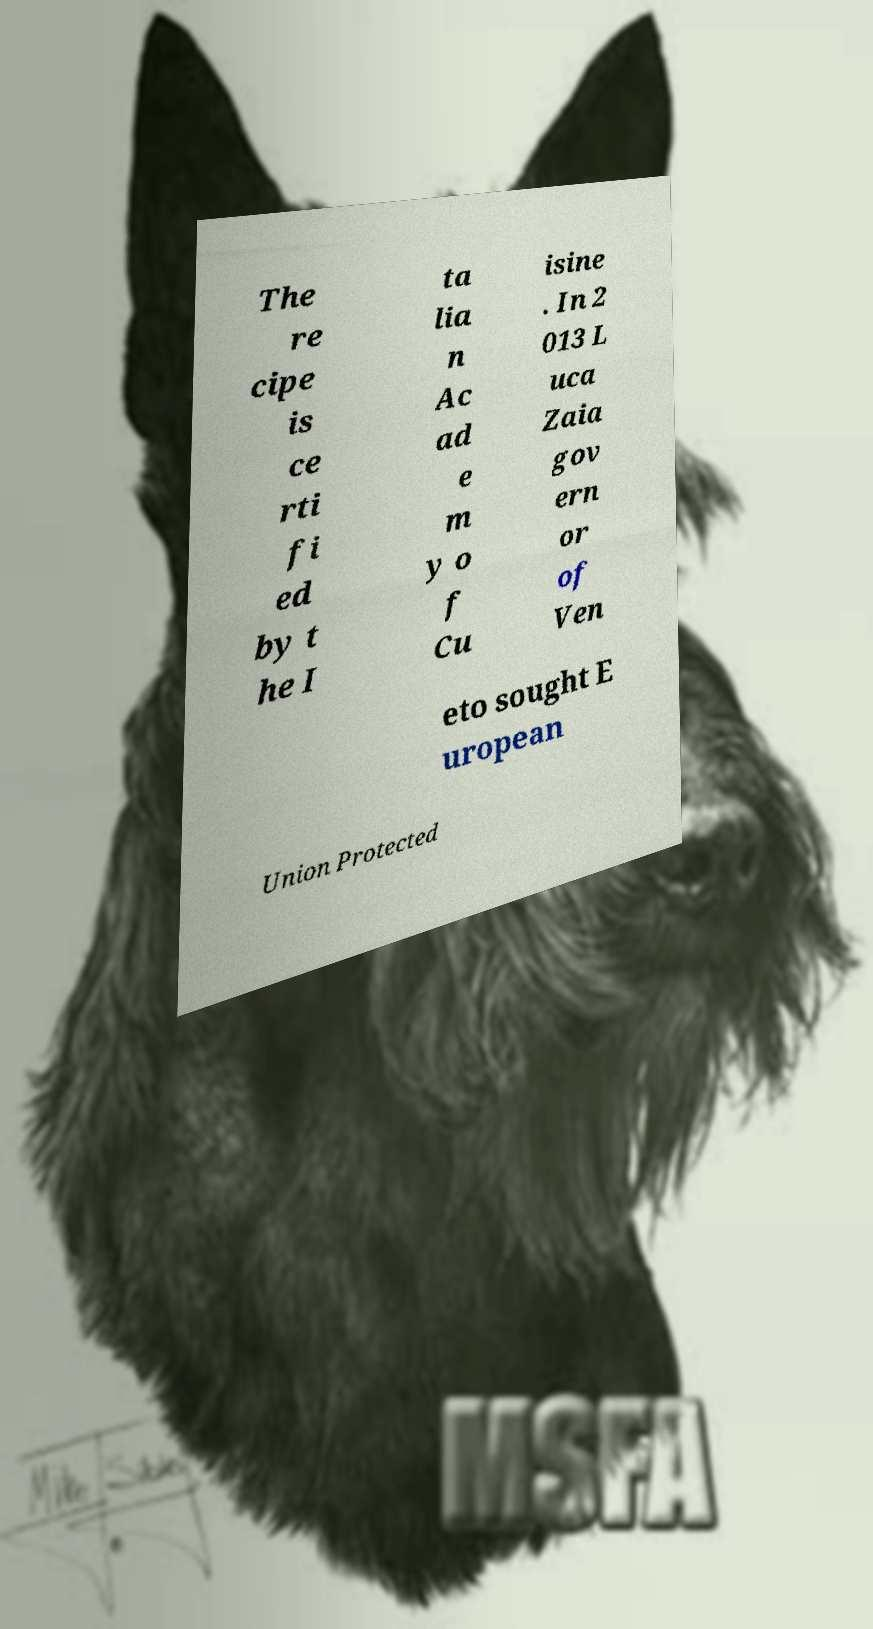There's text embedded in this image that I need extracted. Can you transcribe it verbatim? The re cipe is ce rti fi ed by t he I ta lia n Ac ad e m y o f Cu isine . In 2 013 L uca Zaia gov ern or of Ven eto sought E uropean Union Protected 